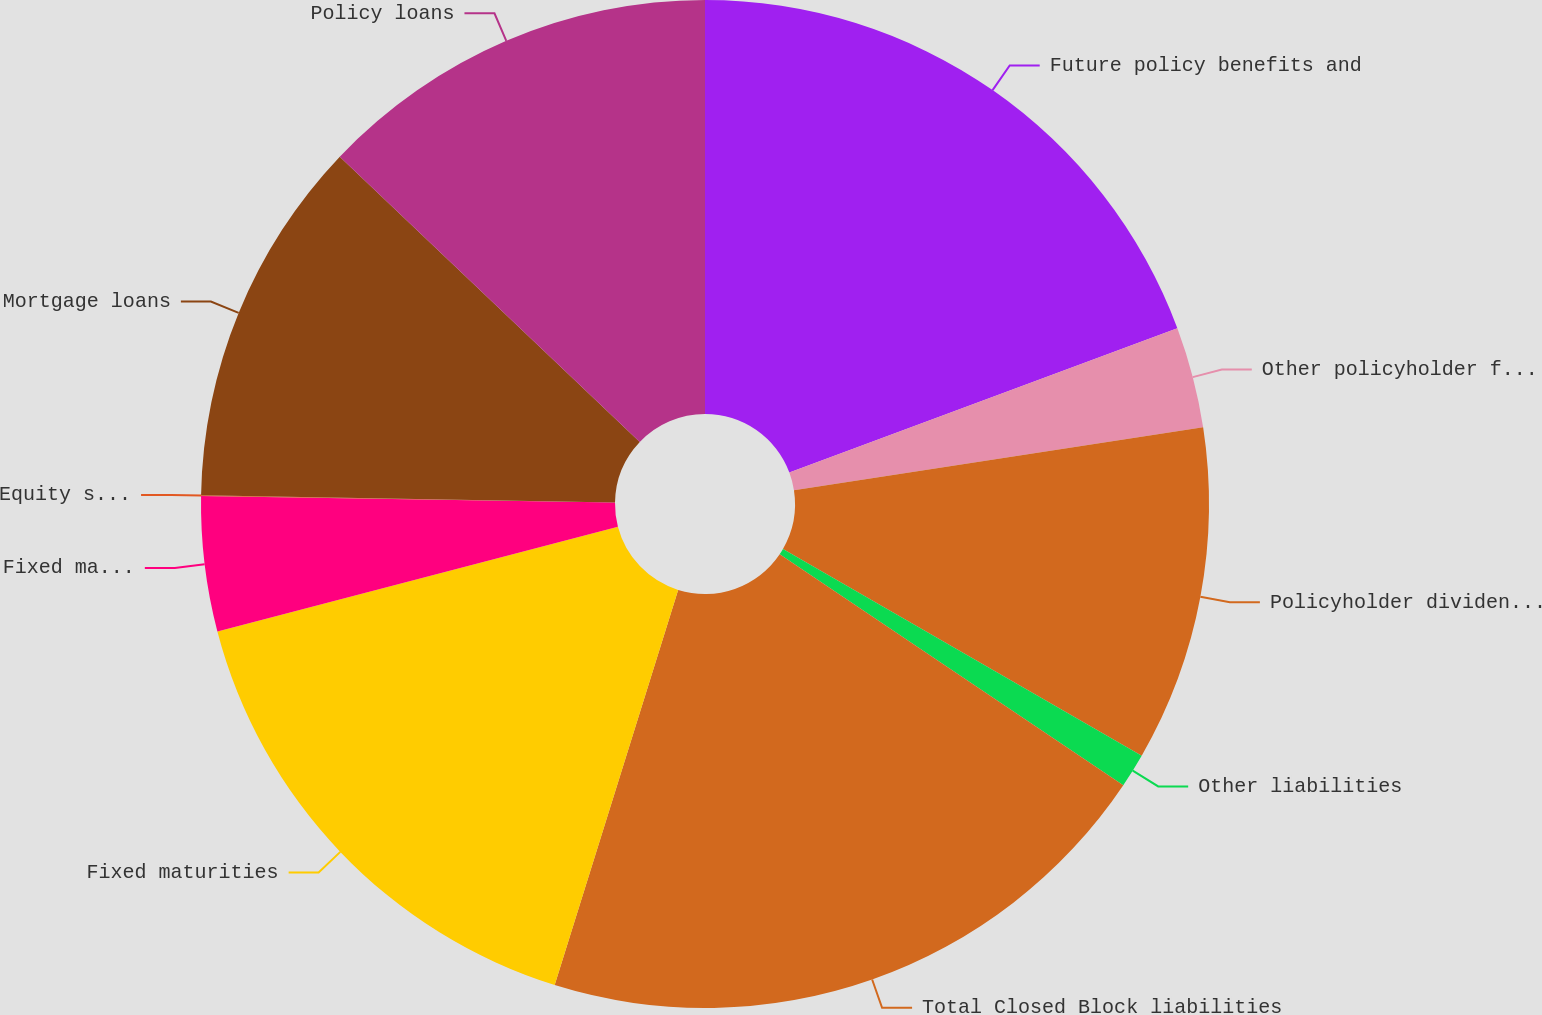<chart> <loc_0><loc_0><loc_500><loc_500><pie_chart><fcel>Future policy benefits and<fcel>Other policyholder funds<fcel>Policyholder dividends payable<fcel>Other liabilities<fcel>Total Closed Block liabilities<fcel>Fixed maturities<fcel>Fixed maturities trading<fcel>Equity securities<fcel>Mortgage loans<fcel>Policy loans<nl><fcel>19.33%<fcel>3.24%<fcel>10.75%<fcel>1.1%<fcel>20.4%<fcel>16.11%<fcel>4.32%<fcel>0.03%<fcel>11.82%<fcel>12.9%<nl></chart> 